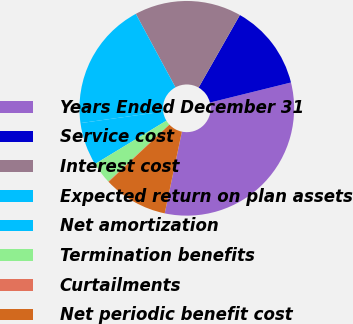<chart> <loc_0><loc_0><loc_500><loc_500><pie_chart><fcel>Years Ended December 31<fcel>Service cost<fcel>Interest cost<fcel>Expected return on plan assets<fcel>Net amortization<fcel>Termination benefits<fcel>Curtailments<fcel>Net periodic benefit cost<nl><fcel>32.16%<fcel>12.9%<fcel>16.11%<fcel>19.32%<fcel>6.48%<fcel>3.27%<fcel>0.06%<fcel>9.69%<nl></chart> 